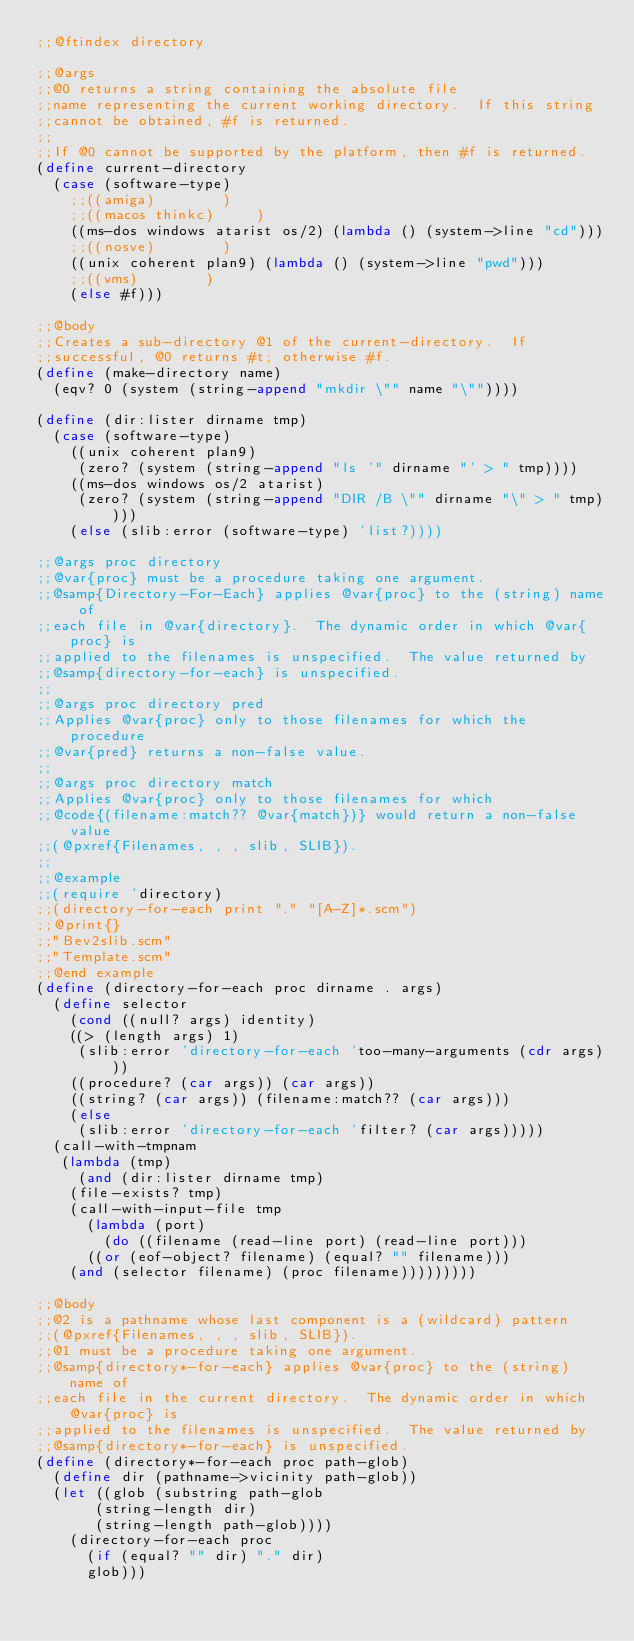Convert code to text. <code><loc_0><loc_0><loc_500><loc_500><_Scheme_>;;@ftindex directory

;;@args
;;@0 returns a string containing the absolute file
;;name representing the current working directory.  If this string
;;cannot be obtained, #f is returned.
;;
;;If @0 cannot be supported by the platform, then #f is returned.
(define current-directory
  (case (software-type)
    ;;((amiga)				)
    ;;((macos thinkc)			)
    ((ms-dos windows atarist os/2) (lambda () (system->line "cd")))
    ;;((nosve)				)
    ((unix coherent plan9) (lambda () (system->line "pwd")))
    ;;((vms)				)
    (else #f)))

;;@body
;;Creates a sub-directory @1 of the current-directory.  If
;;successful, @0 returns #t; otherwise #f.
(define (make-directory name)
  (eqv? 0 (system (string-append "mkdir \"" name "\""))))

(define (dir:lister dirname tmp)
  (case (software-type)
    ((unix coherent plan9)
     (zero? (system (string-append "ls '" dirname "' > " tmp))))
    ((ms-dos windows os/2 atarist)
     (zero? (system (string-append "DIR /B \"" dirname "\" > " tmp))))
    (else (slib:error (software-type) 'list?))))

;;@args proc directory
;;@var{proc} must be a procedure taking one argument.
;;@samp{Directory-For-Each} applies @var{proc} to the (string) name of
;;each file in @var{directory}.  The dynamic order in which @var{proc} is
;;applied to the filenames is unspecified.  The value returned by
;;@samp{directory-for-each} is unspecified.
;;
;;@args proc directory pred
;;Applies @var{proc} only to those filenames for which the procedure
;;@var{pred} returns a non-false value.
;;
;;@args proc directory match
;;Applies @var{proc} only to those filenames for which
;;@code{(filename:match?? @var{match})} would return a non-false value
;;(@pxref{Filenames, , , slib, SLIB}).
;;
;;@example
;;(require 'directory)
;;(directory-for-each print "." "[A-Z]*.scm")
;;@print{}
;;"Bev2slib.scm"
;;"Template.scm"
;;@end example
(define (directory-for-each proc dirname . args)
  (define selector
    (cond ((null? args) identity)
	  ((> (length args) 1)
	   (slib:error 'directory-for-each 'too-many-arguments (cdr args)))
	  ((procedure? (car args)) (car args))
	  ((string? (car args)) (filename:match?? (car args)))
	  (else
	   (slib:error 'directory-for-each 'filter? (car args)))))
  (call-with-tmpnam
   (lambda (tmp)
     (and (dir:lister dirname tmp)
	  (file-exists? tmp)
	  (call-with-input-file tmp
	    (lambda (port)
	      (do ((filename (read-line port) (read-line port)))
		  ((or (eof-object? filename) (equal? "" filename)))
		(and (selector filename) (proc filename)))))))))

;;@body
;;@2 is a pathname whose last component is a (wildcard) pattern
;;(@pxref{Filenames, , , slib, SLIB}).
;;@1 must be a procedure taking one argument.
;;@samp{directory*-for-each} applies @var{proc} to the (string) name of
;;each file in the current directory.  The dynamic order in which @var{proc} is
;;applied to the filenames is unspecified.  The value returned by
;;@samp{directory*-for-each} is unspecified.
(define (directory*-for-each proc path-glob)
  (define dir (pathname->vicinity path-glob))
  (let ((glob (substring path-glob
			 (string-length dir)
			 (string-length path-glob))))
    (directory-for-each proc
			(if (equal? "" dir) "." dir)
			glob)))
</code> 